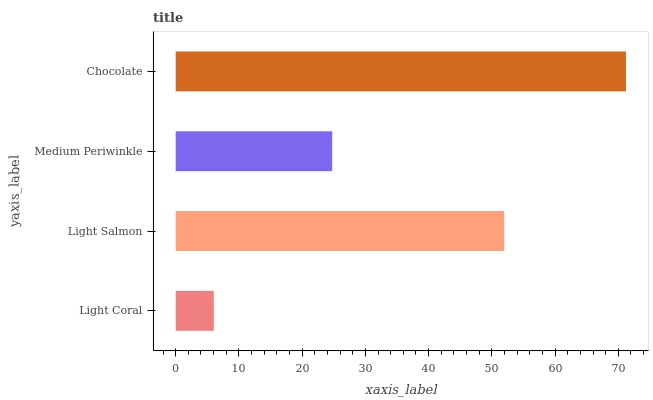Is Light Coral the minimum?
Answer yes or no. Yes. Is Chocolate the maximum?
Answer yes or no. Yes. Is Light Salmon the minimum?
Answer yes or no. No. Is Light Salmon the maximum?
Answer yes or no. No. Is Light Salmon greater than Light Coral?
Answer yes or no. Yes. Is Light Coral less than Light Salmon?
Answer yes or no. Yes. Is Light Coral greater than Light Salmon?
Answer yes or no. No. Is Light Salmon less than Light Coral?
Answer yes or no. No. Is Light Salmon the high median?
Answer yes or no. Yes. Is Medium Periwinkle the low median?
Answer yes or no. Yes. Is Medium Periwinkle the high median?
Answer yes or no. No. Is Chocolate the low median?
Answer yes or no. No. 